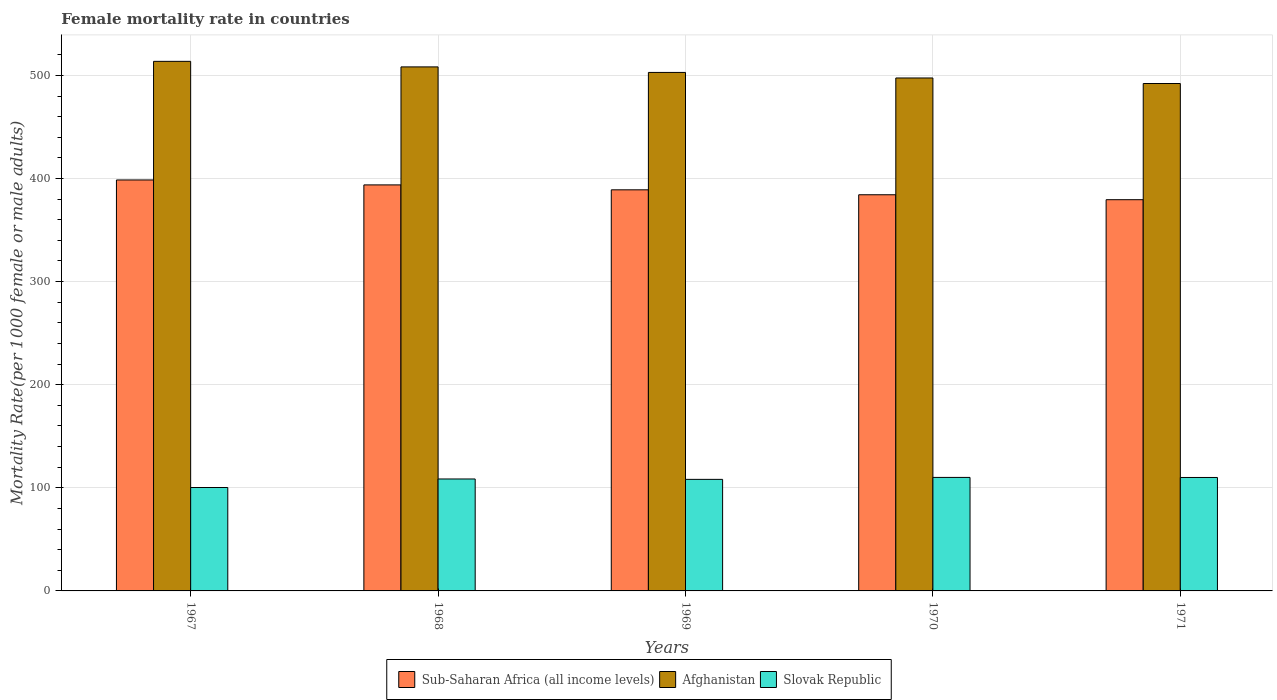How many groups of bars are there?
Offer a very short reply. 5. Are the number of bars per tick equal to the number of legend labels?
Keep it short and to the point. Yes. Are the number of bars on each tick of the X-axis equal?
Ensure brevity in your answer.  Yes. How many bars are there on the 3rd tick from the left?
Ensure brevity in your answer.  3. How many bars are there on the 4th tick from the right?
Provide a succinct answer. 3. What is the label of the 3rd group of bars from the left?
Offer a terse response. 1969. What is the female mortality rate in Afghanistan in 1968?
Provide a short and direct response. 508.26. Across all years, what is the maximum female mortality rate in Sub-Saharan Africa (all income levels)?
Your response must be concise. 398.59. Across all years, what is the minimum female mortality rate in Afghanistan?
Your answer should be very brief. 492.14. In which year was the female mortality rate in Afghanistan maximum?
Ensure brevity in your answer.  1967. In which year was the female mortality rate in Afghanistan minimum?
Provide a short and direct response. 1971. What is the total female mortality rate in Slovak Republic in the graph?
Your response must be concise. 537.19. What is the difference between the female mortality rate in Sub-Saharan Africa (all income levels) in 1968 and that in 1969?
Provide a succinct answer. 4.78. What is the difference between the female mortality rate in Sub-Saharan Africa (all income levels) in 1969 and the female mortality rate in Afghanistan in 1970?
Your answer should be compact. -108.48. What is the average female mortality rate in Slovak Republic per year?
Provide a succinct answer. 107.44. In the year 1968, what is the difference between the female mortality rate in Slovak Republic and female mortality rate in Sub-Saharan Africa (all income levels)?
Provide a succinct answer. -285.23. What is the ratio of the female mortality rate in Sub-Saharan Africa (all income levels) in 1967 to that in 1968?
Keep it short and to the point. 1.01. What is the difference between the highest and the second highest female mortality rate in Afghanistan?
Give a very brief answer. 5.37. What is the difference between the highest and the lowest female mortality rate in Sub-Saharan Africa (all income levels)?
Give a very brief answer. 19.14. What does the 1st bar from the left in 1967 represents?
Ensure brevity in your answer.  Sub-Saharan Africa (all income levels). What does the 3rd bar from the right in 1969 represents?
Offer a terse response. Sub-Saharan Africa (all income levels). Is it the case that in every year, the sum of the female mortality rate in Sub-Saharan Africa (all income levels) and female mortality rate in Slovak Republic is greater than the female mortality rate in Afghanistan?
Keep it short and to the point. No. How many bars are there?
Offer a very short reply. 15. Are all the bars in the graph horizontal?
Your answer should be very brief. No. Are the values on the major ticks of Y-axis written in scientific E-notation?
Offer a terse response. No. Does the graph contain any zero values?
Your answer should be compact. No. Does the graph contain grids?
Provide a short and direct response. Yes. What is the title of the graph?
Offer a terse response. Female mortality rate in countries. What is the label or title of the Y-axis?
Your response must be concise. Mortality Rate(per 1000 female or male adults). What is the Mortality Rate(per 1000 female or male adults) in Sub-Saharan Africa (all income levels) in 1967?
Keep it short and to the point. 398.59. What is the Mortality Rate(per 1000 female or male adults) of Afghanistan in 1967?
Provide a short and direct response. 513.63. What is the Mortality Rate(per 1000 female or male adults) in Slovak Republic in 1967?
Give a very brief answer. 100.29. What is the Mortality Rate(per 1000 female or male adults) of Sub-Saharan Africa (all income levels) in 1968?
Your answer should be compact. 393.81. What is the Mortality Rate(per 1000 female or male adults) in Afghanistan in 1968?
Your answer should be very brief. 508.26. What is the Mortality Rate(per 1000 female or male adults) of Slovak Republic in 1968?
Provide a short and direct response. 108.58. What is the Mortality Rate(per 1000 female or male adults) of Sub-Saharan Africa (all income levels) in 1969?
Ensure brevity in your answer.  389.03. What is the Mortality Rate(per 1000 female or male adults) of Afghanistan in 1969?
Give a very brief answer. 502.88. What is the Mortality Rate(per 1000 female or male adults) in Slovak Republic in 1969?
Offer a terse response. 108.19. What is the Mortality Rate(per 1000 female or male adults) of Sub-Saharan Africa (all income levels) in 1970?
Make the answer very short. 384.24. What is the Mortality Rate(per 1000 female or male adults) of Afghanistan in 1970?
Your response must be concise. 497.51. What is the Mortality Rate(per 1000 female or male adults) in Slovak Republic in 1970?
Provide a succinct answer. 110.1. What is the Mortality Rate(per 1000 female or male adults) in Sub-Saharan Africa (all income levels) in 1971?
Provide a succinct answer. 379.45. What is the Mortality Rate(per 1000 female or male adults) of Afghanistan in 1971?
Offer a very short reply. 492.14. What is the Mortality Rate(per 1000 female or male adults) of Slovak Republic in 1971?
Your answer should be compact. 110.03. Across all years, what is the maximum Mortality Rate(per 1000 female or male adults) in Sub-Saharan Africa (all income levels)?
Your answer should be compact. 398.59. Across all years, what is the maximum Mortality Rate(per 1000 female or male adults) in Afghanistan?
Ensure brevity in your answer.  513.63. Across all years, what is the maximum Mortality Rate(per 1000 female or male adults) of Slovak Republic?
Make the answer very short. 110.1. Across all years, what is the minimum Mortality Rate(per 1000 female or male adults) in Sub-Saharan Africa (all income levels)?
Offer a terse response. 379.45. Across all years, what is the minimum Mortality Rate(per 1000 female or male adults) of Afghanistan?
Make the answer very short. 492.14. Across all years, what is the minimum Mortality Rate(per 1000 female or male adults) in Slovak Republic?
Provide a short and direct response. 100.29. What is the total Mortality Rate(per 1000 female or male adults) in Sub-Saharan Africa (all income levels) in the graph?
Make the answer very short. 1945.12. What is the total Mortality Rate(per 1000 female or male adults) in Afghanistan in the graph?
Give a very brief answer. 2514.42. What is the total Mortality Rate(per 1000 female or male adults) in Slovak Republic in the graph?
Provide a short and direct response. 537.19. What is the difference between the Mortality Rate(per 1000 female or male adults) in Sub-Saharan Africa (all income levels) in 1967 and that in 1968?
Offer a terse response. 4.79. What is the difference between the Mortality Rate(per 1000 female or male adults) in Afghanistan in 1967 and that in 1968?
Your response must be concise. 5.37. What is the difference between the Mortality Rate(per 1000 female or male adults) in Slovak Republic in 1967 and that in 1968?
Your answer should be very brief. -8.28. What is the difference between the Mortality Rate(per 1000 female or male adults) of Sub-Saharan Africa (all income levels) in 1967 and that in 1969?
Your answer should be compact. 9.56. What is the difference between the Mortality Rate(per 1000 female or male adults) of Afghanistan in 1967 and that in 1969?
Your answer should be compact. 10.75. What is the difference between the Mortality Rate(per 1000 female or male adults) of Slovak Republic in 1967 and that in 1969?
Your response must be concise. -7.9. What is the difference between the Mortality Rate(per 1000 female or male adults) in Sub-Saharan Africa (all income levels) in 1967 and that in 1970?
Your answer should be very brief. 14.35. What is the difference between the Mortality Rate(per 1000 female or male adults) of Afghanistan in 1967 and that in 1970?
Provide a succinct answer. 16.12. What is the difference between the Mortality Rate(per 1000 female or male adults) of Slovak Republic in 1967 and that in 1970?
Your answer should be very brief. -9.8. What is the difference between the Mortality Rate(per 1000 female or male adults) of Sub-Saharan Africa (all income levels) in 1967 and that in 1971?
Your answer should be compact. 19.14. What is the difference between the Mortality Rate(per 1000 female or male adults) in Afghanistan in 1967 and that in 1971?
Offer a terse response. 21.5. What is the difference between the Mortality Rate(per 1000 female or male adults) of Slovak Republic in 1967 and that in 1971?
Your answer should be compact. -9.74. What is the difference between the Mortality Rate(per 1000 female or male adults) of Sub-Saharan Africa (all income levels) in 1968 and that in 1969?
Provide a succinct answer. 4.78. What is the difference between the Mortality Rate(per 1000 female or male adults) of Afghanistan in 1968 and that in 1969?
Provide a succinct answer. 5.37. What is the difference between the Mortality Rate(per 1000 female or male adults) in Slovak Republic in 1968 and that in 1969?
Give a very brief answer. 0.39. What is the difference between the Mortality Rate(per 1000 female or male adults) in Sub-Saharan Africa (all income levels) in 1968 and that in 1970?
Offer a terse response. 9.56. What is the difference between the Mortality Rate(per 1000 female or male adults) in Afghanistan in 1968 and that in 1970?
Give a very brief answer. 10.75. What is the difference between the Mortality Rate(per 1000 female or male adults) of Slovak Republic in 1968 and that in 1970?
Give a very brief answer. -1.52. What is the difference between the Mortality Rate(per 1000 female or male adults) of Sub-Saharan Africa (all income levels) in 1968 and that in 1971?
Provide a short and direct response. 14.35. What is the difference between the Mortality Rate(per 1000 female or male adults) of Afghanistan in 1968 and that in 1971?
Keep it short and to the point. 16.12. What is the difference between the Mortality Rate(per 1000 female or male adults) in Slovak Republic in 1968 and that in 1971?
Give a very brief answer. -1.45. What is the difference between the Mortality Rate(per 1000 female or male adults) of Sub-Saharan Africa (all income levels) in 1969 and that in 1970?
Your answer should be compact. 4.79. What is the difference between the Mortality Rate(per 1000 female or male adults) of Afghanistan in 1969 and that in 1970?
Make the answer very short. 5.37. What is the difference between the Mortality Rate(per 1000 female or male adults) of Slovak Republic in 1969 and that in 1970?
Your answer should be very brief. -1.91. What is the difference between the Mortality Rate(per 1000 female or male adults) of Sub-Saharan Africa (all income levels) in 1969 and that in 1971?
Ensure brevity in your answer.  9.58. What is the difference between the Mortality Rate(per 1000 female or male adults) in Afghanistan in 1969 and that in 1971?
Your answer should be compact. 10.75. What is the difference between the Mortality Rate(per 1000 female or male adults) of Slovak Republic in 1969 and that in 1971?
Provide a short and direct response. -1.84. What is the difference between the Mortality Rate(per 1000 female or male adults) of Sub-Saharan Africa (all income levels) in 1970 and that in 1971?
Make the answer very short. 4.79. What is the difference between the Mortality Rate(per 1000 female or male adults) of Afghanistan in 1970 and that in 1971?
Give a very brief answer. 5.37. What is the difference between the Mortality Rate(per 1000 female or male adults) of Slovak Republic in 1970 and that in 1971?
Make the answer very short. 0.07. What is the difference between the Mortality Rate(per 1000 female or male adults) of Sub-Saharan Africa (all income levels) in 1967 and the Mortality Rate(per 1000 female or male adults) of Afghanistan in 1968?
Make the answer very short. -109.67. What is the difference between the Mortality Rate(per 1000 female or male adults) of Sub-Saharan Africa (all income levels) in 1967 and the Mortality Rate(per 1000 female or male adults) of Slovak Republic in 1968?
Provide a short and direct response. 290.02. What is the difference between the Mortality Rate(per 1000 female or male adults) in Afghanistan in 1967 and the Mortality Rate(per 1000 female or male adults) in Slovak Republic in 1968?
Your answer should be compact. 405.06. What is the difference between the Mortality Rate(per 1000 female or male adults) in Sub-Saharan Africa (all income levels) in 1967 and the Mortality Rate(per 1000 female or male adults) in Afghanistan in 1969?
Provide a short and direct response. -104.29. What is the difference between the Mortality Rate(per 1000 female or male adults) of Sub-Saharan Africa (all income levels) in 1967 and the Mortality Rate(per 1000 female or male adults) of Slovak Republic in 1969?
Offer a very short reply. 290.4. What is the difference between the Mortality Rate(per 1000 female or male adults) in Afghanistan in 1967 and the Mortality Rate(per 1000 female or male adults) in Slovak Republic in 1969?
Offer a very short reply. 405.44. What is the difference between the Mortality Rate(per 1000 female or male adults) of Sub-Saharan Africa (all income levels) in 1967 and the Mortality Rate(per 1000 female or male adults) of Afghanistan in 1970?
Make the answer very short. -98.92. What is the difference between the Mortality Rate(per 1000 female or male adults) in Sub-Saharan Africa (all income levels) in 1967 and the Mortality Rate(per 1000 female or male adults) in Slovak Republic in 1970?
Your answer should be compact. 288.49. What is the difference between the Mortality Rate(per 1000 female or male adults) in Afghanistan in 1967 and the Mortality Rate(per 1000 female or male adults) in Slovak Republic in 1970?
Ensure brevity in your answer.  403.53. What is the difference between the Mortality Rate(per 1000 female or male adults) of Sub-Saharan Africa (all income levels) in 1967 and the Mortality Rate(per 1000 female or male adults) of Afghanistan in 1971?
Offer a terse response. -93.55. What is the difference between the Mortality Rate(per 1000 female or male adults) of Sub-Saharan Africa (all income levels) in 1967 and the Mortality Rate(per 1000 female or male adults) of Slovak Republic in 1971?
Keep it short and to the point. 288.56. What is the difference between the Mortality Rate(per 1000 female or male adults) of Afghanistan in 1967 and the Mortality Rate(per 1000 female or male adults) of Slovak Republic in 1971?
Your response must be concise. 403.6. What is the difference between the Mortality Rate(per 1000 female or male adults) of Sub-Saharan Africa (all income levels) in 1968 and the Mortality Rate(per 1000 female or male adults) of Afghanistan in 1969?
Ensure brevity in your answer.  -109.08. What is the difference between the Mortality Rate(per 1000 female or male adults) in Sub-Saharan Africa (all income levels) in 1968 and the Mortality Rate(per 1000 female or male adults) in Slovak Republic in 1969?
Your answer should be compact. 285.61. What is the difference between the Mortality Rate(per 1000 female or male adults) of Afghanistan in 1968 and the Mortality Rate(per 1000 female or male adults) of Slovak Republic in 1969?
Give a very brief answer. 400.07. What is the difference between the Mortality Rate(per 1000 female or male adults) in Sub-Saharan Africa (all income levels) in 1968 and the Mortality Rate(per 1000 female or male adults) in Afghanistan in 1970?
Provide a succinct answer. -103.71. What is the difference between the Mortality Rate(per 1000 female or male adults) in Sub-Saharan Africa (all income levels) in 1968 and the Mortality Rate(per 1000 female or male adults) in Slovak Republic in 1970?
Offer a terse response. 283.71. What is the difference between the Mortality Rate(per 1000 female or male adults) in Afghanistan in 1968 and the Mortality Rate(per 1000 female or male adults) in Slovak Republic in 1970?
Ensure brevity in your answer.  398.16. What is the difference between the Mortality Rate(per 1000 female or male adults) of Sub-Saharan Africa (all income levels) in 1968 and the Mortality Rate(per 1000 female or male adults) of Afghanistan in 1971?
Offer a very short reply. -98.33. What is the difference between the Mortality Rate(per 1000 female or male adults) in Sub-Saharan Africa (all income levels) in 1968 and the Mortality Rate(per 1000 female or male adults) in Slovak Republic in 1971?
Give a very brief answer. 283.78. What is the difference between the Mortality Rate(per 1000 female or male adults) in Afghanistan in 1968 and the Mortality Rate(per 1000 female or male adults) in Slovak Republic in 1971?
Give a very brief answer. 398.23. What is the difference between the Mortality Rate(per 1000 female or male adults) in Sub-Saharan Africa (all income levels) in 1969 and the Mortality Rate(per 1000 female or male adults) in Afghanistan in 1970?
Keep it short and to the point. -108.48. What is the difference between the Mortality Rate(per 1000 female or male adults) of Sub-Saharan Africa (all income levels) in 1969 and the Mortality Rate(per 1000 female or male adults) of Slovak Republic in 1970?
Make the answer very short. 278.93. What is the difference between the Mortality Rate(per 1000 female or male adults) in Afghanistan in 1969 and the Mortality Rate(per 1000 female or male adults) in Slovak Republic in 1970?
Your answer should be compact. 392.79. What is the difference between the Mortality Rate(per 1000 female or male adults) in Sub-Saharan Africa (all income levels) in 1969 and the Mortality Rate(per 1000 female or male adults) in Afghanistan in 1971?
Keep it short and to the point. -103.11. What is the difference between the Mortality Rate(per 1000 female or male adults) in Sub-Saharan Africa (all income levels) in 1969 and the Mortality Rate(per 1000 female or male adults) in Slovak Republic in 1971?
Ensure brevity in your answer.  279. What is the difference between the Mortality Rate(per 1000 female or male adults) of Afghanistan in 1969 and the Mortality Rate(per 1000 female or male adults) of Slovak Republic in 1971?
Provide a succinct answer. 392.86. What is the difference between the Mortality Rate(per 1000 female or male adults) of Sub-Saharan Africa (all income levels) in 1970 and the Mortality Rate(per 1000 female or male adults) of Afghanistan in 1971?
Give a very brief answer. -107.89. What is the difference between the Mortality Rate(per 1000 female or male adults) of Sub-Saharan Africa (all income levels) in 1970 and the Mortality Rate(per 1000 female or male adults) of Slovak Republic in 1971?
Your answer should be compact. 274.21. What is the difference between the Mortality Rate(per 1000 female or male adults) of Afghanistan in 1970 and the Mortality Rate(per 1000 female or male adults) of Slovak Republic in 1971?
Your answer should be compact. 387.48. What is the average Mortality Rate(per 1000 female or male adults) of Sub-Saharan Africa (all income levels) per year?
Provide a succinct answer. 389.02. What is the average Mortality Rate(per 1000 female or male adults) of Afghanistan per year?
Your answer should be compact. 502.88. What is the average Mortality Rate(per 1000 female or male adults) of Slovak Republic per year?
Your response must be concise. 107.44. In the year 1967, what is the difference between the Mortality Rate(per 1000 female or male adults) of Sub-Saharan Africa (all income levels) and Mortality Rate(per 1000 female or male adults) of Afghanistan?
Ensure brevity in your answer.  -115.04. In the year 1967, what is the difference between the Mortality Rate(per 1000 female or male adults) of Sub-Saharan Africa (all income levels) and Mortality Rate(per 1000 female or male adults) of Slovak Republic?
Your answer should be compact. 298.3. In the year 1967, what is the difference between the Mortality Rate(per 1000 female or male adults) in Afghanistan and Mortality Rate(per 1000 female or male adults) in Slovak Republic?
Offer a terse response. 413.34. In the year 1968, what is the difference between the Mortality Rate(per 1000 female or male adults) in Sub-Saharan Africa (all income levels) and Mortality Rate(per 1000 female or male adults) in Afghanistan?
Offer a very short reply. -114.45. In the year 1968, what is the difference between the Mortality Rate(per 1000 female or male adults) in Sub-Saharan Africa (all income levels) and Mortality Rate(per 1000 female or male adults) in Slovak Republic?
Keep it short and to the point. 285.23. In the year 1968, what is the difference between the Mortality Rate(per 1000 female or male adults) of Afghanistan and Mortality Rate(per 1000 female or male adults) of Slovak Republic?
Give a very brief answer. 399.68. In the year 1969, what is the difference between the Mortality Rate(per 1000 female or male adults) in Sub-Saharan Africa (all income levels) and Mortality Rate(per 1000 female or male adults) in Afghanistan?
Ensure brevity in your answer.  -113.86. In the year 1969, what is the difference between the Mortality Rate(per 1000 female or male adults) in Sub-Saharan Africa (all income levels) and Mortality Rate(per 1000 female or male adults) in Slovak Republic?
Your answer should be compact. 280.84. In the year 1969, what is the difference between the Mortality Rate(per 1000 female or male adults) in Afghanistan and Mortality Rate(per 1000 female or male adults) in Slovak Republic?
Your response must be concise. 394.69. In the year 1970, what is the difference between the Mortality Rate(per 1000 female or male adults) of Sub-Saharan Africa (all income levels) and Mortality Rate(per 1000 female or male adults) of Afghanistan?
Give a very brief answer. -113.27. In the year 1970, what is the difference between the Mortality Rate(per 1000 female or male adults) in Sub-Saharan Africa (all income levels) and Mortality Rate(per 1000 female or male adults) in Slovak Republic?
Your response must be concise. 274.14. In the year 1970, what is the difference between the Mortality Rate(per 1000 female or male adults) in Afghanistan and Mortality Rate(per 1000 female or male adults) in Slovak Republic?
Give a very brief answer. 387.41. In the year 1971, what is the difference between the Mortality Rate(per 1000 female or male adults) in Sub-Saharan Africa (all income levels) and Mortality Rate(per 1000 female or male adults) in Afghanistan?
Your answer should be compact. -112.68. In the year 1971, what is the difference between the Mortality Rate(per 1000 female or male adults) of Sub-Saharan Africa (all income levels) and Mortality Rate(per 1000 female or male adults) of Slovak Republic?
Ensure brevity in your answer.  269.42. In the year 1971, what is the difference between the Mortality Rate(per 1000 female or male adults) of Afghanistan and Mortality Rate(per 1000 female or male adults) of Slovak Republic?
Your answer should be compact. 382.11. What is the ratio of the Mortality Rate(per 1000 female or male adults) in Sub-Saharan Africa (all income levels) in 1967 to that in 1968?
Provide a short and direct response. 1.01. What is the ratio of the Mortality Rate(per 1000 female or male adults) in Afghanistan in 1967 to that in 1968?
Your response must be concise. 1.01. What is the ratio of the Mortality Rate(per 1000 female or male adults) in Slovak Republic in 1967 to that in 1968?
Your answer should be compact. 0.92. What is the ratio of the Mortality Rate(per 1000 female or male adults) of Sub-Saharan Africa (all income levels) in 1967 to that in 1969?
Offer a terse response. 1.02. What is the ratio of the Mortality Rate(per 1000 female or male adults) in Afghanistan in 1967 to that in 1969?
Make the answer very short. 1.02. What is the ratio of the Mortality Rate(per 1000 female or male adults) in Slovak Republic in 1967 to that in 1969?
Keep it short and to the point. 0.93. What is the ratio of the Mortality Rate(per 1000 female or male adults) of Sub-Saharan Africa (all income levels) in 1967 to that in 1970?
Make the answer very short. 1.04. What is the ratio of the Mortality Rate(per 1000 female or male adults) of Afghanistan in 1967 to that in 1970?
Your answer should be compact. 1.03. What is the ratio of the Mortality Rate(per 1000 female or male adults) in Slovak Republic in 1967 to that in 1970?
Offer a very short reply. 0.91. What is the ratio of the Mortality Rate(per 1000 female or male adults) of Sub-Saharan Africa (all income levels) in 1967 to that in 1971?
Make the answer very short. 1.05. What is the ratio of the Mortality Rate(per 1000 female or male adults) in Afghanistan in 1967 to that in 1971?
Make the answer very short. 1.04. What is the ratio of the Mortality Rate(per 1000 female or male adults) of Slovak Republic in 1967 to that in 1971?
Your response must be concise. 0.91. What is the ratio of the Mortality Rate(per 1000 female or male adults) of Sub-Saharan Africa (all income levels) in 1968 to that in 1969?
Keep it short and to the point. 1.01. What is the ratio of the Mortality Rate(per 1000 female or male adults) in Afghanistan in 1968 to that in 1969?
Provide a short and direct response. 1.01. What is the ratio of the Mortality Rate(per 1000 female or male adults) of Sub-Saharan Africa (all income levels) in 1968 to that in 1970?
Your response must be concise. 1.02. What is the ratio of the Mortality Rate(per 1000 female or male adults) in Afghanistan in 1968 to that in 1970?
Your answer should be very brief. 1.02. What is the ratio of the Mortality Rate(per 1000 female or male adults) in Slovak Republic in 1968 to that in 1970?
Offer a very short reply. 0.99. What is the ratio of the Mortality Rate(per 1000 female or male adults) of Sub-Saharan Africa (all income levels) in 1968 to that in 1971?
Give a very brief answer. 1.04. What is the ratio of the Mortality Rate(per 1000 female or male adults) of Afghanistan in 1968 to that in 1971?
Keep it short and to the point. 1.03. What is the ratio of the Mortality Rate(per 1000 female or male adults) of Slovak Republic in 1968 to that in 1971?
Provide a short and direct response. 0.99. What is the ratio of the Mortality Rate(per 1000 female or male adults) in Sub-Saharan Africa (all income levels) in 1969 to that in 1970?
Ensure brevity in your answer.  1.01. What is the ratio of the Mortality Rate(per 1000 female or male adults) in Afghanistan in 1969 to that in 1970?
Provide a short and direct response. 1.01. What is the ratio of the Mortality Rate(per 1000 female or male adults) in Slovak Republic in 1969 to that in 1970?
Keep it short and to the point. 0.98. What is the ratio of the Mortality Rate(per 1000 female or male adults) of Sub-Saharan Africa (all income levels) in 1969 to that in 1971?
Ensure brevity in your answer.  1.03. What is the ratio of the Mortality Rate(per 1000 female or male adults) in Afghanistan in 1969 to that in 1971?
Provide a short and direct response. 1.02. What is the ratio of the Mortality Rate(per 1000 female or male adults) in Slovak Republic in 1969 to that in 1971?
Offer a terse response. 0.98. What is the ratio of the Mortality Rate(per 1000 female or male adults) in Sub-Saharan Africa (all income levels) in 1970 to that in 1971?
Your answer should be very brief. 1.01. What is the ratio of the Mortality Rate(per 1000 female or male adults) in Afghanistan in 1970 to that in 1971?
Make the answer very short. 1.01. What is the ratio of the Mortality Rate(per 1000 female or male adults) of Slovak Republic in 1970 to that in 1971?
Your answer should be compact. 1. What is the difference between the highest and the second highest Mortality Rate(per 1000 female or male adults) in Sub-Saharan Africa (all income levels)?
Your answer should be very brief. 4.79. What is the difference between the highest and the second highest Mortality Rate(per 1000 female or male adults) of Afghanistan?
Ensure brevity in your answer.  5.37. What is the difference between the highest and the second highest Mortality Rate(per 1000 female or male adults) of Slovak Republic?
Your answer should be compact. 0.07. What is the difference between the highest and the lowest Mortality Rate(per 1000 female or male adults) of Sub-Saharan Africa (all income levels)?
Provide a succinct answer. 19.14. What is the difference between the highest and the lowest Mortality Rate(per 1000 female or male adults) in Afghanistan?
Your response must be concise. 21.5. What is the difference between the highest and the lowest Mortality Rate(per 1000 female or male adults) in Slovak Republic?
Keep it short and to the point. 9.8. 